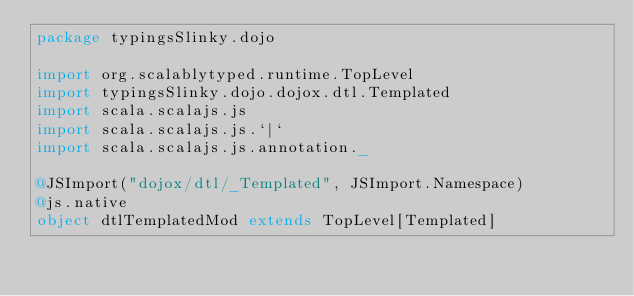Convert code to text. <code><loc_0><loc_0><loc_500><loc_500><_Scala_>package typingsSlinky.dojo

import org.scalablytyped.runtime.TopLevel
import typingsSlinky.dojo.dojox.dtl.Templated
import scala.scalajs.js
import scala.scalajs.js.`|`
import scala.scalajs.js.annotation._

@JSImport("dojox/dtl/_Templated", JSImport.Namespace)
@js.native
object dtlTemplatedMod extends TopLevel[Templated]

</code> 